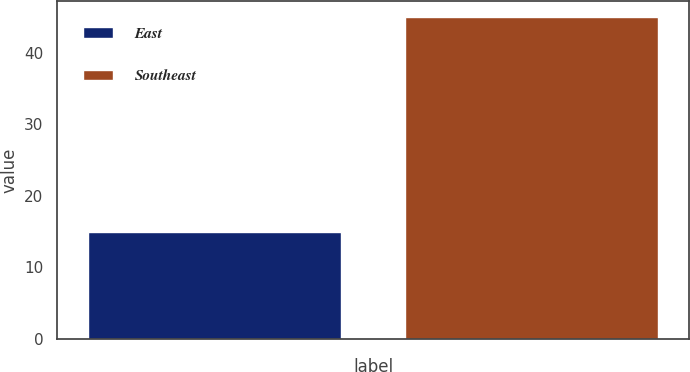Convert chart. <chart><loc_0><loc_0><loc_500><loc_500><bar_chart><fcel>East<fcel>Southeast<nl><fcel>15<fcel>45<nl></chart> 